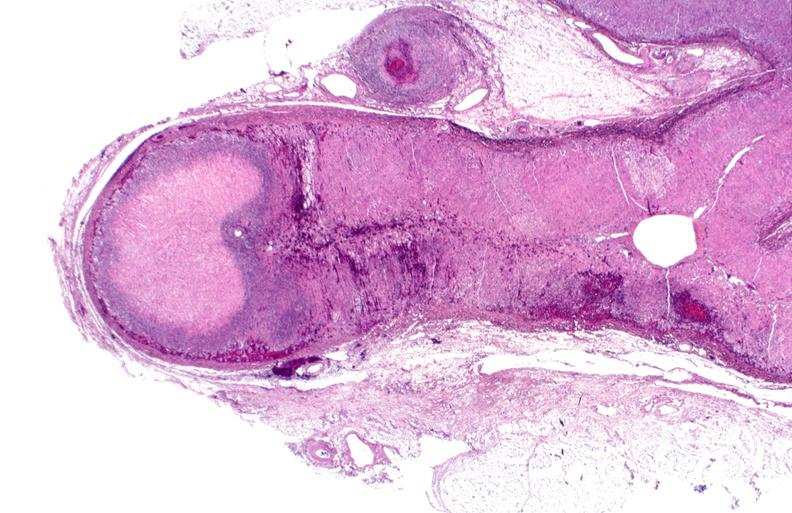s myocardial infarct present?
Answer the question using a single word or phrase. No 